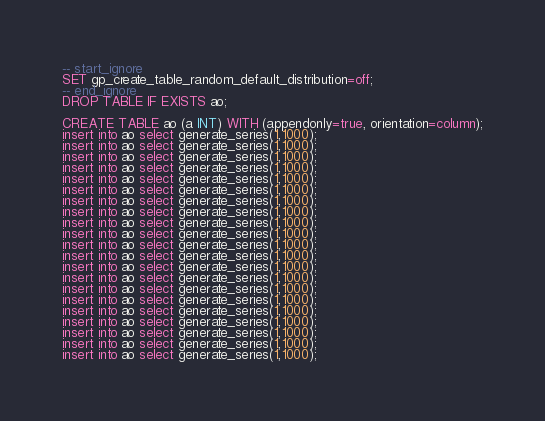Convert code to text. <code><loc_0><loc_0><loc_500><loc_500><_SQL_>-- start_ignore
SET gp_create_table_random_default_distribution=off;
-- end_ignore
DROP TABLE IF EXISTS ao;

CREATE TABLE ao (a INT) WITH (appendonly=true, orientation=column);
insert into ao select generate_series(1,1000);
insert into ao select generate_series(1,1000);
insert into ao select generate_series(1,1000);
insert into ao select generate_series(1,1000);
insert into ao select generate_series(1,1000);
insert into ao select generate_series(1,1000);
insert into ao select generate_series(1,1000);
insert into ao select generate_series(1,1000);
insert into ao select generate_series(1,1000);
insert into ao select generate_series(1,1000);
insert into ao select generate_series(1,1000);
insert into ao select generate_series(1,1000);
insert into ao select generate_series(1,1000);
insert into ao select generate_series(1,1000);
insert into ao select generate_series(1,1000);
insert into ao select generate_series(1,1000);
insert into ao select generate_series(1,1000);
insert into ao select generate_series(1,1000);
insert into ao select generate_series(1,1000);
insert into ao select generate_series(1,1000);
insert into ao select generate_series(1,1000);

</code> 